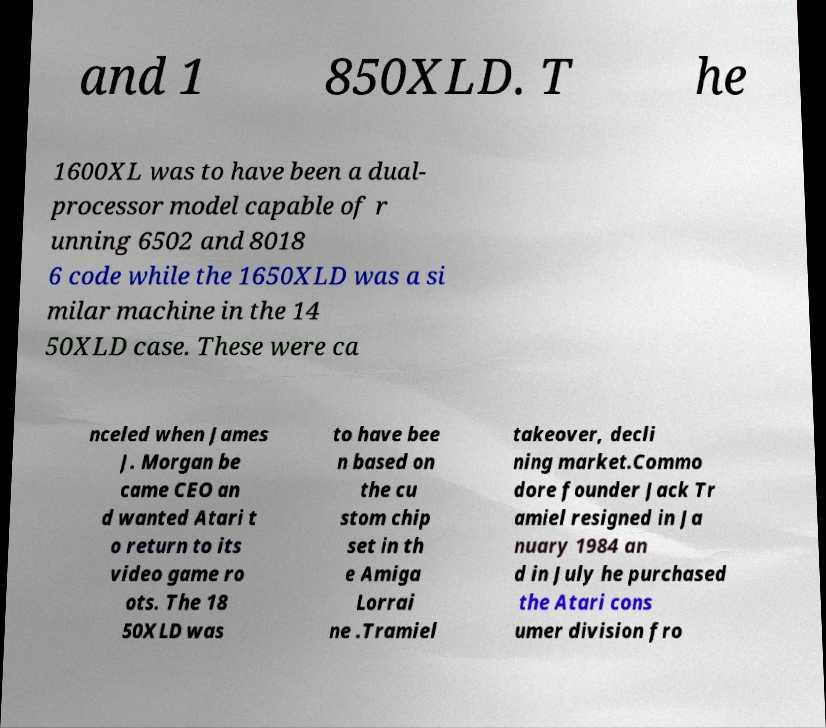For documentation purposes, I need the text within this image transcribed. Could you provide that? and 1 850XLD. T he 1600XL was to have been a dual- processor model capable of r unning 6502 and 8018 6 code while the 1650XLD was a si milar machine in the 14 50XLD case. These were ca nceled when James J. Morgan be came CEO an d wanted Atari t o return to its video game ro ots. The 18 50XLD was to have bee n based on the cu stom chip set in th e Amiga Lorrai ne .Tramiel takeover, decli ning market.Commo dore founder Jack Tr amiel resigned in Ja nuary 1984 an d in July he purchased the Atari cons umer division fro 